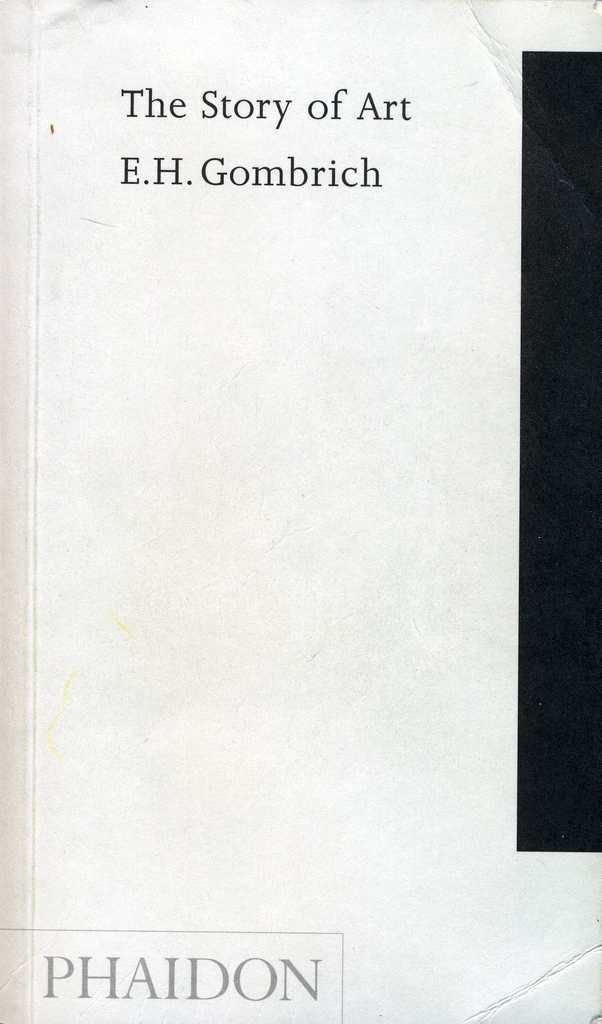<image>
Describe the image concisely. White book cover written by "E.H. Gombrich" and titled "The story of art". 